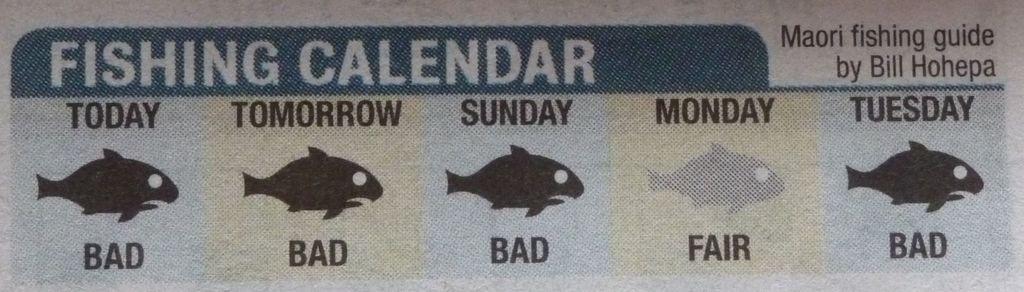Please provide a concise description of this image. In this picture I can see text on the paper and few cartoon images. 